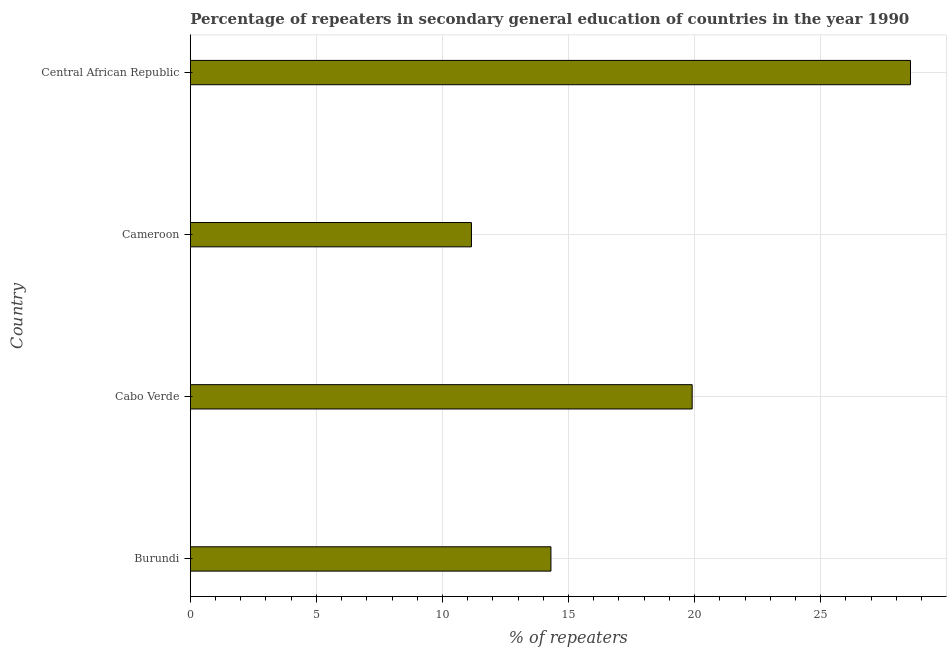What is the title of the graph?
Give a very brief answer. Percentage of repeaters in secondary general education of countries in the year 1990. What is the label or title of the X-axis?
Make the answer very short. % of repeaters. What is the label or title of the Y-axis?
Ensure brevity in your answer.  Country. What is the percentage of repeaters in Cameroon?
Offer a very short reply. 11.15. Across all countries, what is the maximum percentage of repeaters?
Give a very brief answer. 28.56. Across all countries, what is the minimum percentage of repeaters?
Your answer should be very brief. 11.15. In which country was the percentage of repeaters maximum?
Your response must be concise. Central African Republic. In which country was the percentage of repeaters minimum?
Your response must be concise. Cameroon. What is the sum of the percentage of repeaters?
Offer a terse response. 73.92. What is the difference between the percentage of repeaters in Burundi and Cameroon?
Make the answer very short. 3.15. What is the average percentage of repeaters per country?
Make the answer very short. 18.48. What is the median percentage of repeaters?
Make the answer very short. 17.1. What is the ratio of the percentage of repeaters in Burundi to that in Central African Republic?
Keep it short and to the point. 0.5. Is the difference between the percentage of repeaters in Burundi and Cabo Verde greater than the difference between any two countries?
Your answer should be compact. No. What is the difference between the highest and the second highest percentage of repeaters?
Give a very brief answer. 8.66. What is the difference between the highest and the lowest percentage of repeaters?
Ensure brevity in your answer.  17.41. What is the difference between two consecutive major ticks on the X-axis?
Keep it short and to the point. 5. What is the % of repeaters in Burundi?
Your response must be concise. 14.3. What is the % of repeaters in Cabo Verde?
Provide a succinct answer. 19.9. What is the % of repeaters of Cameroon?
Ensure brevity in your answer.  11.15. What is the % of repeaters in Central African Republic?
Make the answer very short. 28.56. What is the difference between the % of repeaters in Burundi and Cabo Verde?
Give a very brief answer. -5.6. What is the difference between the % of repeaters in Burundi and Cameroon?
Give a very brief answer. 3.15. What is the difference between the % of repeaters in Burundi and Central African Republic?
Your answer should be very brief. -14.26. What is the difference between the % of repeaters in Cabo Verde and Cameroon?
Ensure brevity in your answer.  8.75. What is the difference between the % of repeaters in Cabo Verde and Central African Republic?
Offer a very short reply. -8.66. What is the difference between the % of repeaters in Cameroon and Central African Republic?
Offer a very short reply. -17.41. What is the ratio of the % of repeaters in Burundi to that in Cabo Verde?
Your answer should be very brief. 0.72. What is the ratio of the % of repeaters in Burundi to that in Cameroon?
Your answer should be very brief. 1.28. What is the ratio of the % of repeaters in Burundi to that in Central African Republic?
Keep it short and to the point. 0.5. What is the ratio of the % of repeaters in Cabo Verde to that in Cameroon?
Your answer should be very brief. 1.78. What is the ratio of the % of repeaters in Cabo Verde to that in Central African Republic?
Offer a very short reply. 0.7. What is the ratio of the % of repeaters in Cameroon to that in Central African Republic?
Give a very brief answer. 0.39. 